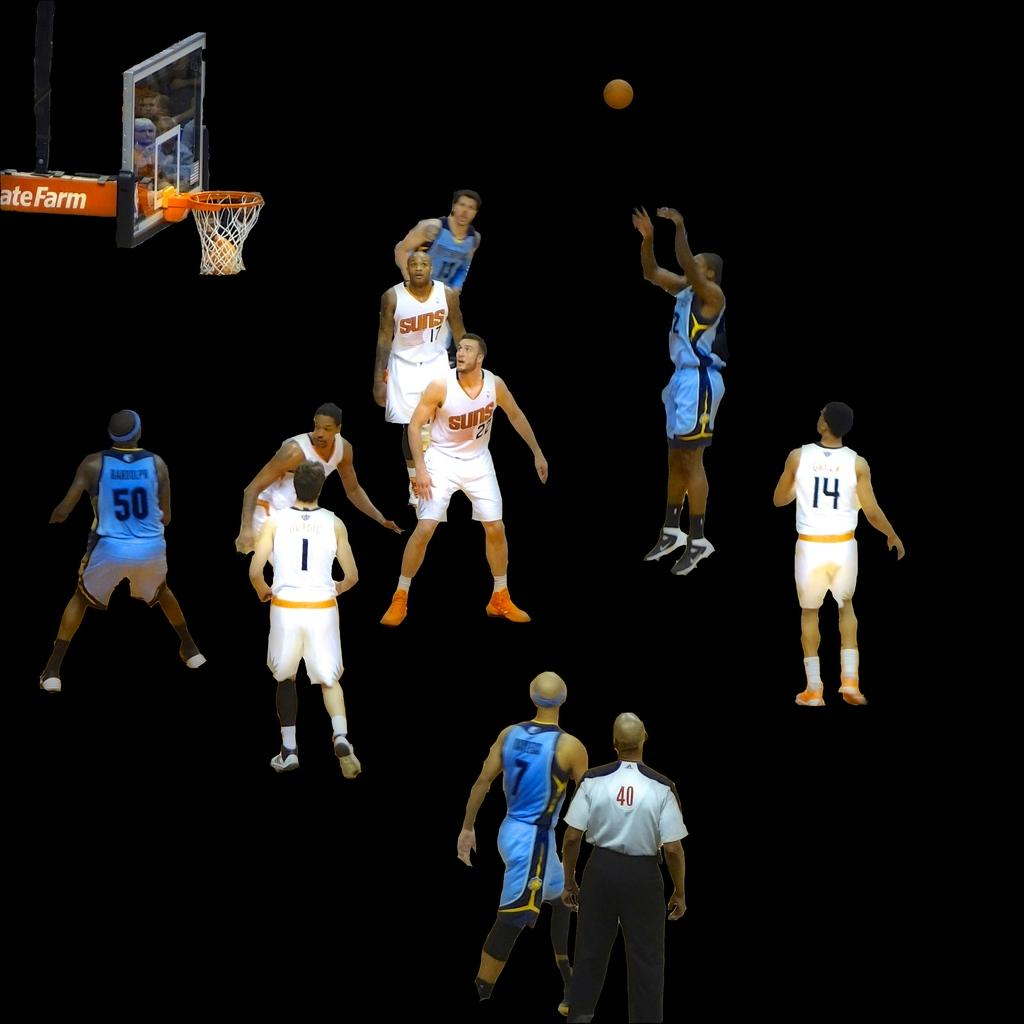<image>
Summarize the visual content of the image. the number 14 that is on a player 